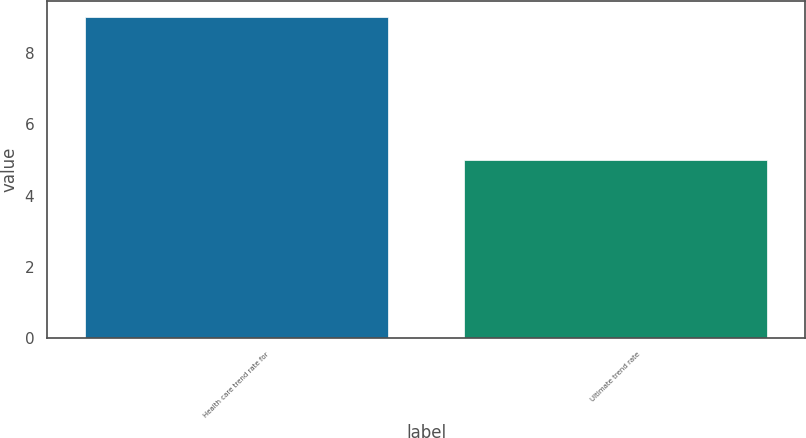<chart> <loc_0><loc_0><loc_500><loc_500><bar_chart><fcel>Health care trend rate for<fcel>Ultimate trend rate<nl><fcel>9<fcel>5<nl></chart> 